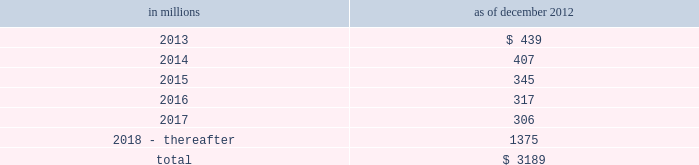Notes to consolidated financial statements sumitomo mitsui financial group , inc .
( smfg ) provides the firm with credit loss protection on certain approved loan commitments ( primarily investment-grade commercial lending commitments ) .
The notional amount of such loan commitments was $ 32.41 billion and $ 31.94 billion as of december 2012 and december 2011 , respectively .
The credit loss protection on loan commitments provided by smfg is generally limited to 95% ( 95 % ) of the first loss the firm realizes on such commitments , up to a maximum of approximately $ 950 million .
In addition , subject to the satisfaction of certain conditions , upon the firm 2019s request , smfg will provide protection for 70% ( 70 % ) of additional losses on such commitments , up to a maximum of $ 1.13 billion , of which $ 300 million of protection had been provided as of both december 2012 and december 2011 .
The firm also uses other financial instruments to mitigate credit risks related to certain commitments not covered by smfg .
These instruments primarily include credit default swaps that reference the same or similar underlying instrument or entity or credit default swaps that reference a market index .
Warehouse financing .
The firm provides financing to clients who warehouse financial assets .
These arrangements are secured by the warehoused assets , primarily consisting of commercial mortgage loans .
Contingent and forward starting resale and securities borrowing agreements/forward starting repurchase and secured lending agreements the firm enters into resale and securities borrowing agreements and repurchase and secured lending agreements that settle at a future date .
The firm also enters into commitments to provide contingent financing to its clients and counterparties through resale agreements .
The firm 2019s funding of these commitments depends on the satisfaction of all contractual conditions to the resale agreement and these commitments can expire unused .
Investment commitments the firm 2019s investment commitments consist of commitments to invest in private equity , real estate and other assets directly and through funds that the firm raises and manages .
These commitments include $ 872 million and $ 1.62 billion as of december 2012 and december 2011 , respectively , related to real estate private investments and $ 6.47 billion and $ 7.50 billion as of december 2012 and december 2011 , respectively , related to corporate and other private investments .
Of these amounts , $ 6.21 billion and $ 8.38 billion as of december 2012 and december 2011 , respectively , relate to commitments to invest in funds managed by the firm , which will be funded at market value on the date of investment .
Leases the firm has contractual obligations under long-term noncancelable lease agreements , principally for office space , expiring on various dates through 2069 .
Certain agreements are subject to periodic escalation provisions for increases in real estate taxes and other charges .
The table below presents future minimum rental payments , net of minimum sublease rentals .
In millions december 2012 .
Rent charged to operating expense for the years ended december 2012 , december 2011 and december 2010 was $ 374 million , $ 475 million and $ 508 million , respectively .
Operating leases include office space held in excess of current requirements .
Rent expense relating to space held for growth is included in 201coccupancy . 201d the firm records a liability , based on the fair value of the remaining lease rentals reduced by any potential or existing sublease rentals , for leases where the firm has ceased using the space and management has concluded that the firm will not derive any future economic benefits .
Costs to terminate a lease before the end of its term are recognized and measured at fair value on termination .
Goldman sachs 2012 annual report 175 .
What percentage of future minimum rental payments is due in 2015? 
Computations: (345 / 3189)
Answer: 0.10818. 